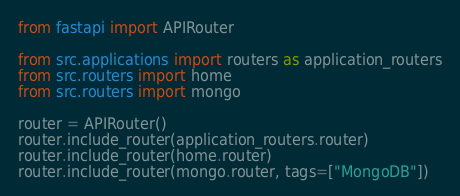<code> <loc_0><loc_0><loc_500><loc_500><_Python_>from fastapi import APIRouter

from src.applications import routers as application_routers
from src.routers import home
from src.routers import mongo

router = APIRouter()
router.include_router(application_routers.router)
router.include_router(home.router)
router.include_router(mongo.router, tags=["MongoDB"])
</code> 